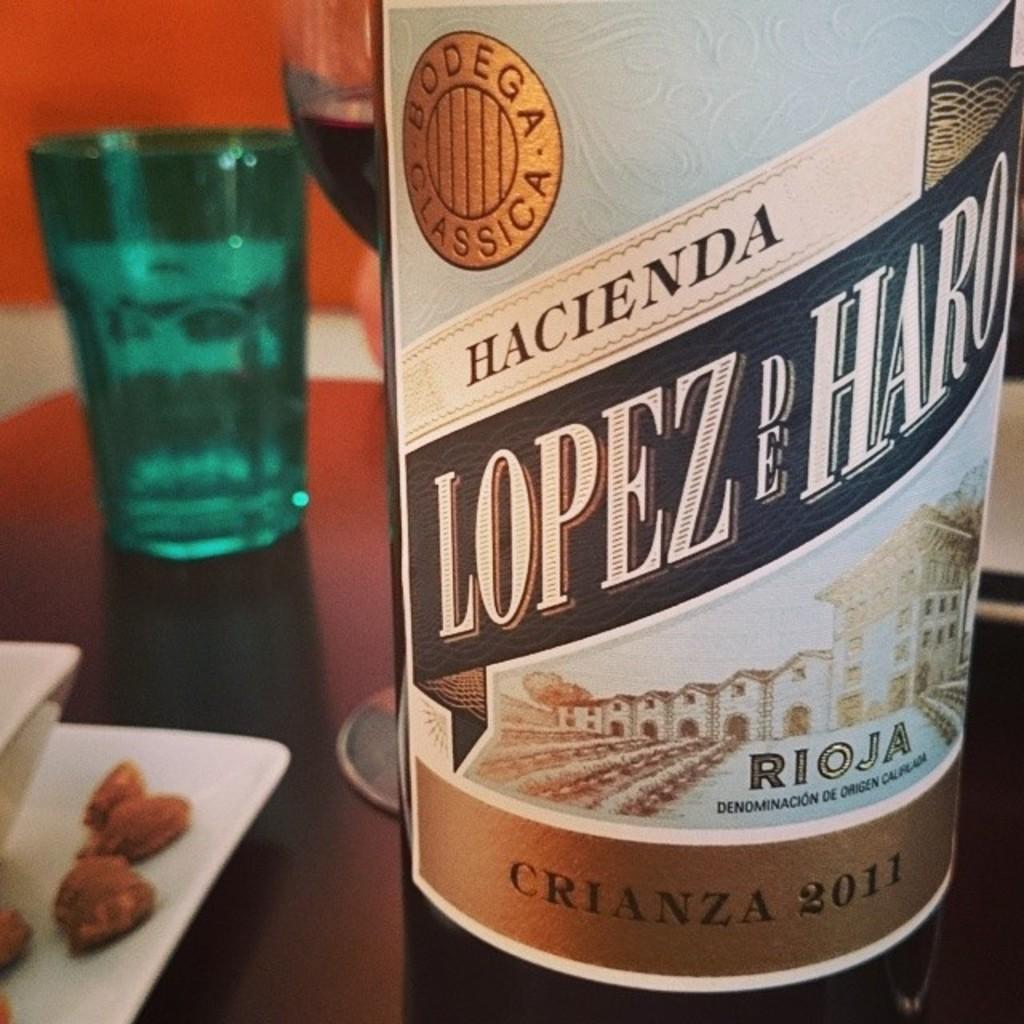What year is think wine from?
Keep it short and to the point. 2011. What brand is this?
Make the answer very short. Hacienda. 